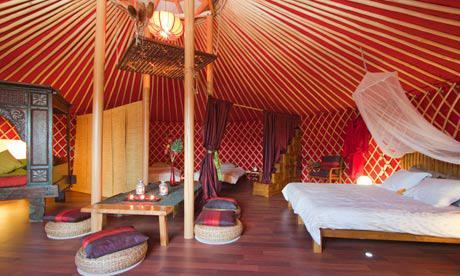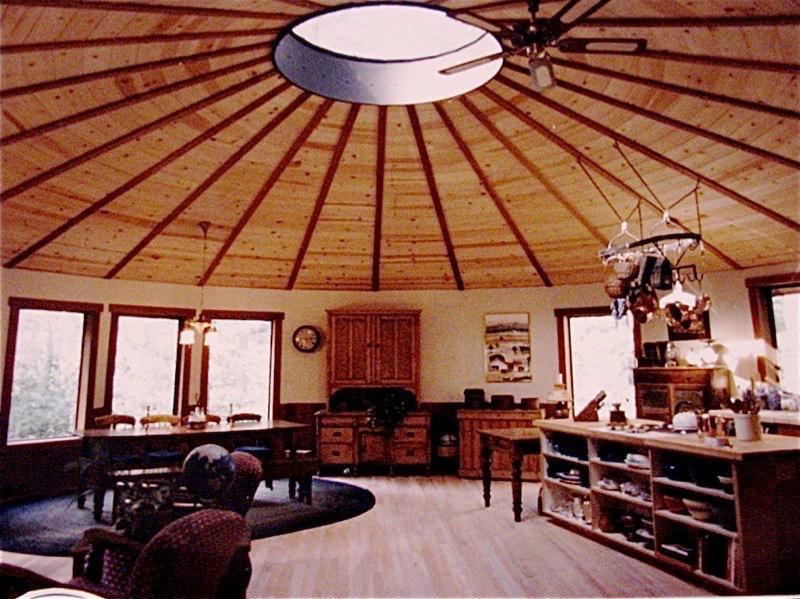The first image is the image on the left, the second image is the image on the right. For the images displayed, is the sentence "The building is located near trees." factually correct? Answer yes or no. No. 